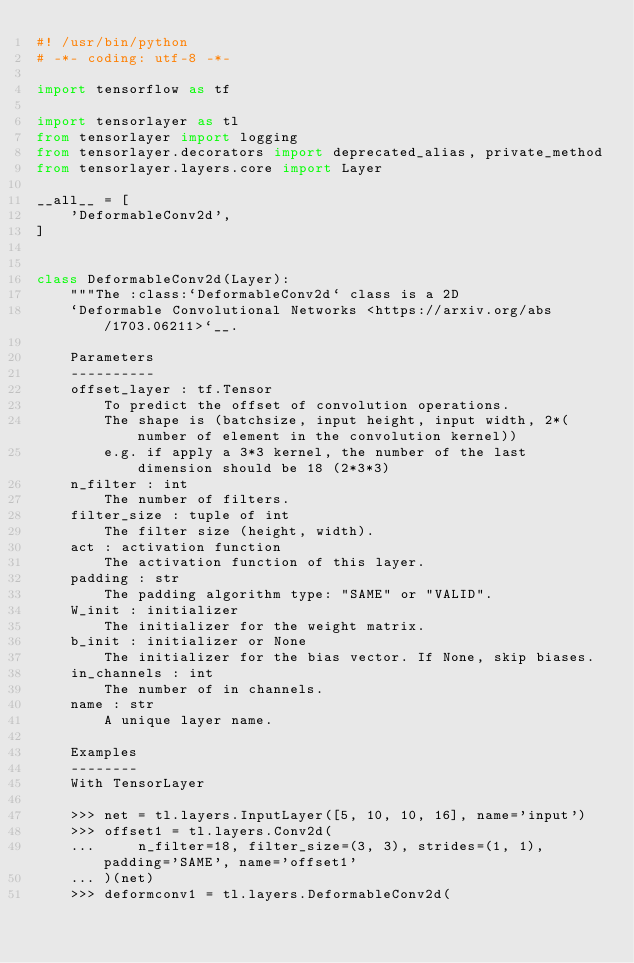<code> <loc_0><loc_0><loc_500><loc_500><_Python_>#! /usr/bin/python
# -*- coding: utf-8 -*-

import tensorflow as tf

import tensorlayer as tl
from tensorlayer import logging
from tensorlayer.decorators import deprecated_alias, private_method
from tensorlayer.layers.core import Layer

__all__ = [
    'DeformableConv2d',
]


class DeformableConv2d(Layer):
    """The :class:`DeformableConv2d` class is a 2D
    `Deformable Convolutional Networks <https://arxiv.org/abs/1703.06211>`__.

    Parameters
    ----------
    offset_layer : tf.Tensor
        To predict the offset of convolution operations.
        The shape is (batchsize, input height, input width, 2*(number of element in the convolution kernel))
        e.g. if apply a 3*3 kernel, the number of the last dimension should be 18 (2*3*3)
    n_filter : int
        The number of filters.
    filter_size : tuple of int
        The filter size (height, width).
    act : activation function
        The activation function of this layer.
    padding : str
        The padding algorithm type: "SAME" or "VALID".
    W_init : initializer
        The initializer for the weight matrix.
    b_init : initializer or None
        The initializer for the bias vector. If None, skip biases.
    in_channels : int
        The number of in channels.
    name : str
        A unique layer name.

    Examples
    --------
    With TensorLayer

    >>> net = tl.layers.InputLayer([5, 10, 10, 16], name='input')
    >>> offset1 = tl.layers.Conv2d(
    ...     n_filter=18, filter_size=(3, 3), strides=(1, 1), padding='SAME', name='offset1'
    ... )(net)
    >>> deformconv1 = tl.layers.DeformableConv2d(</code> 